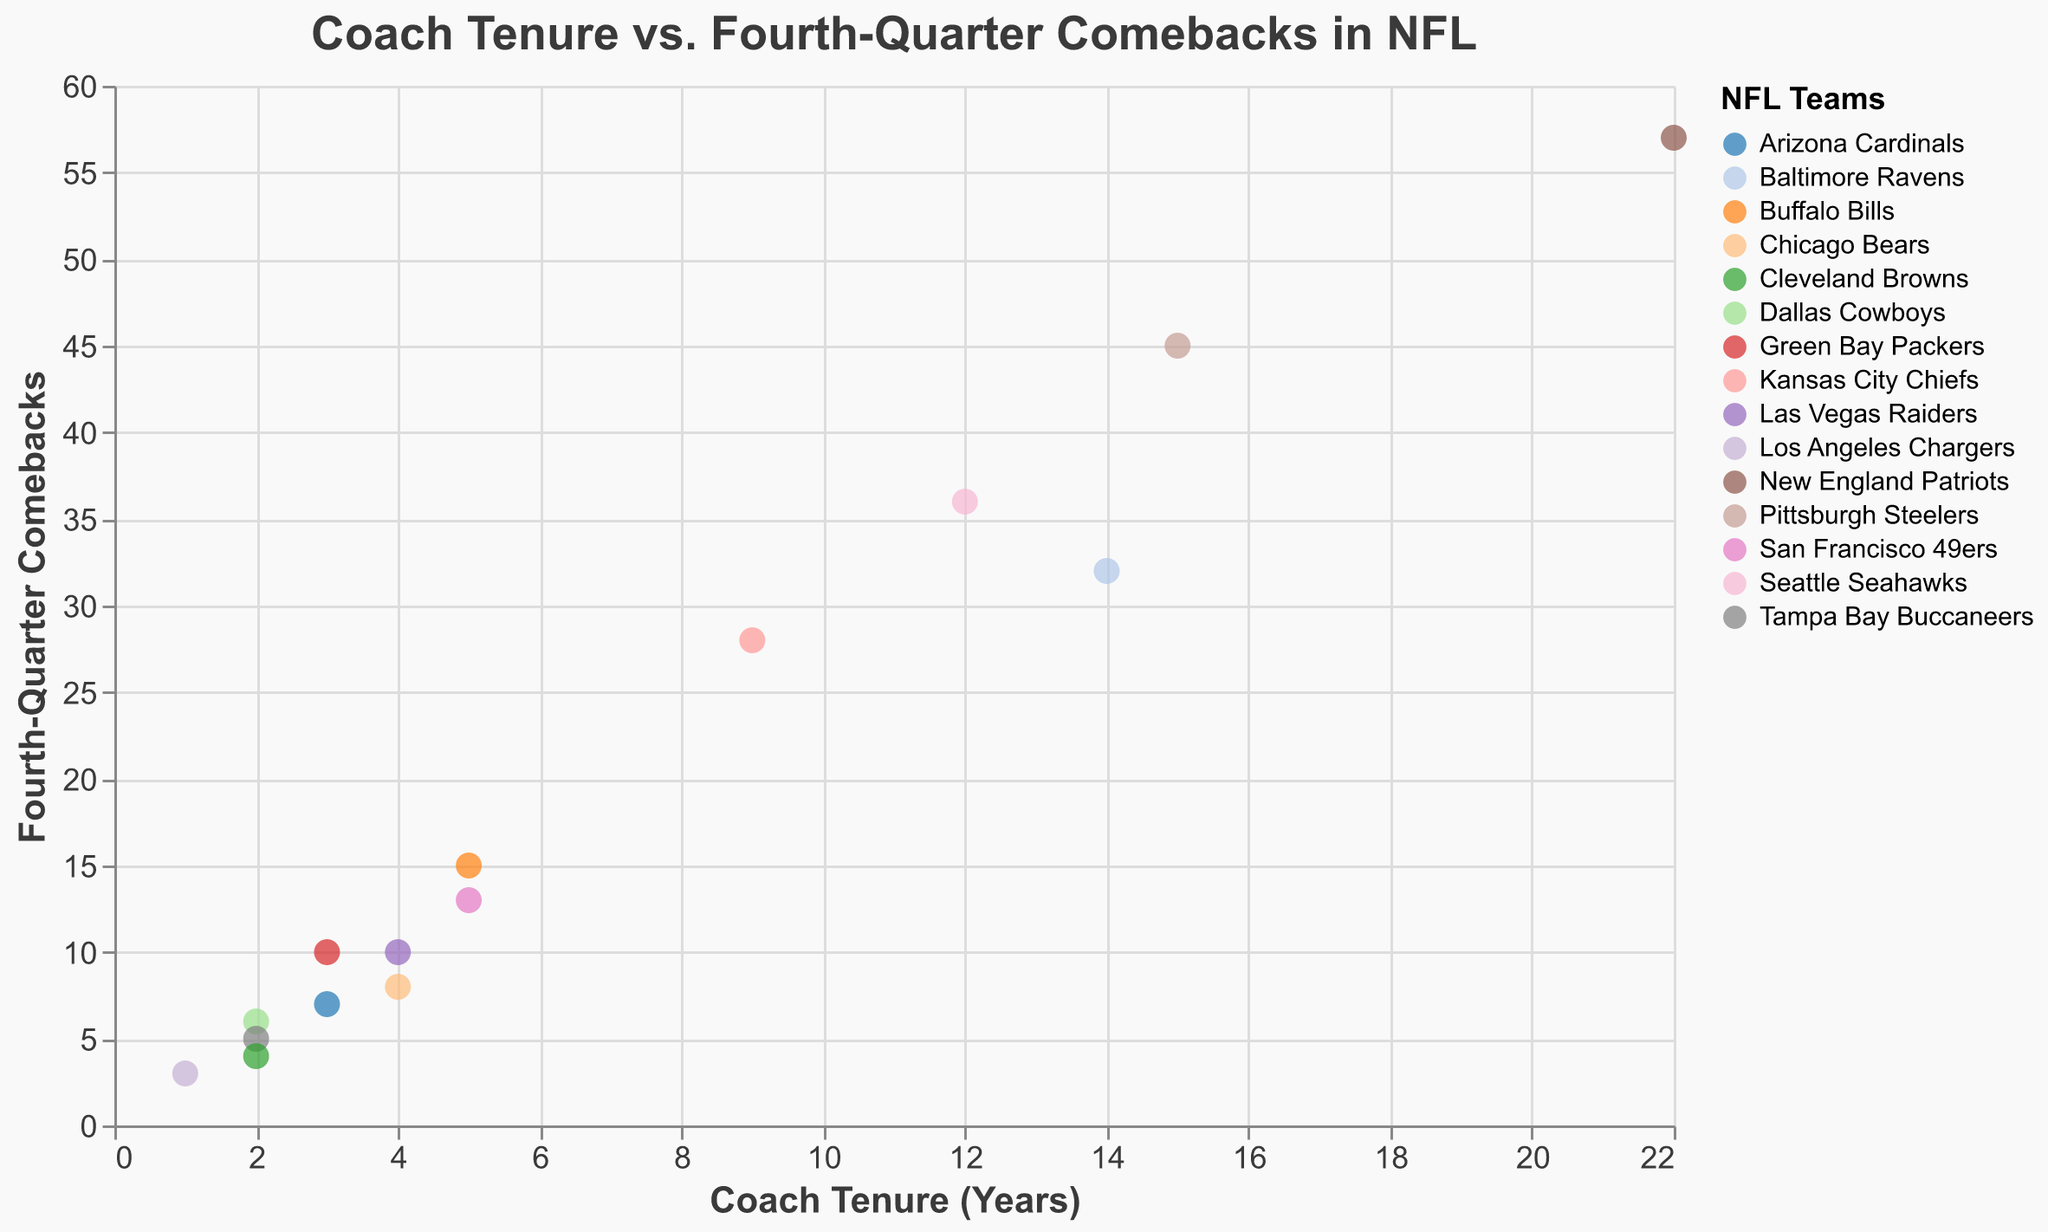What is the title of the scatter plot? The title of the scatter plot is mentioned at the top of the chart in bold, larger font size. The text is "Coach Tenure vs. Fourth-Quarter Comebacks in NFL."
Answer: Coach Tenure vs. Fourth-Quarter Comebacks in NFL How many teams are represented in the scatter plot? By looking at the number of unique colors in the legend of the scatter plot, each corresponding to a different team, we can count the number of teams. There are 15 data points each representing a different team.
Answer: 15 Which coach has the longest tenure? The scatter plot's x-axis represents the tenure of each coach in years. The furthest point on the right along the x-axis corresponds to the longest tenure. Bill Belichick has the longest tenure of 22 years.
Answer: Bill Belichick Which team has the highest number of fourth-quarter comebacks? The y-axis shows the number of fourth-quarter comebacks. The point highest on the y-axis corresponds to the team with the highest number. The New England Patriots have the highest number with 57 comebacks.
Answer: New England Patriots Compare Andy Reid and Pete Carroll. Who has more fourth-quarter comebacks? The chart shows the number of fourth-quarter comebacks on the y-axis. By locating the points for Andy Reid (28 comebacks) and Pete Carroll (36 comebacks) along the y-axis, we can compare them. Pete Carroll has more comebacks.
Answer: Pete Carroll What's the average number of fourth-quarter comebacks for coaches with more than 10 years of tenure? Select data points with tenure > 10 years (Bill Belichick, Mike Tomlin, Pete Carroll, John Harbaugh). Sum their comebacks (57 + 45 + 36 + 32 = 170) and divide by the count (4). The average is 170/4 = 42.5.
Answer: 42.5 Which team has the shortest tenure but a relatively higher number of fourth-quarter comebacks? Identify teams with the shortest tenures from the x-axis. Among them (Brandon Staley 1 year, Mike McCarthy 2 years, Bruce Arians 2 years, Kevin Stefanski 2 years), compare on y-axis. Mike McCarthy has 6 comebacks with 2 years tenure.
Answer: Dallas Cowboys (Mike McCarthy) Is there a positive relationship between coach tenure and the number of fourth-quarter comebacks? Evaluate the overall trend of the points in the scatter plot. Most points showing higher tenures also have higher comebacks, indicating a positive relationship between tenure and comebacks.
Answer: Yes Which coach has a tenure of 3 years and how many fourth-quarter comebacks does he have? Locate data points where x = 3 on the scatter plot, which correspond to tenures of 3 years, and check their y values. The coaches are Matt LaFleur with 10 comebacks and Klingsbury with 7 comebacks.
Answer: Matt LaFleur (10), Klingsbury (7) What is the sum of fourth-quarter comebacks for coaches who have 4 years of tenure? Identify data points where x = 4 (Jon Gruden, Matt Nagy). Sum their y values (Jon Gruden 10 + Matt Nagy 8 = 18). The sum of comebacks is 18.
Answer: 18 